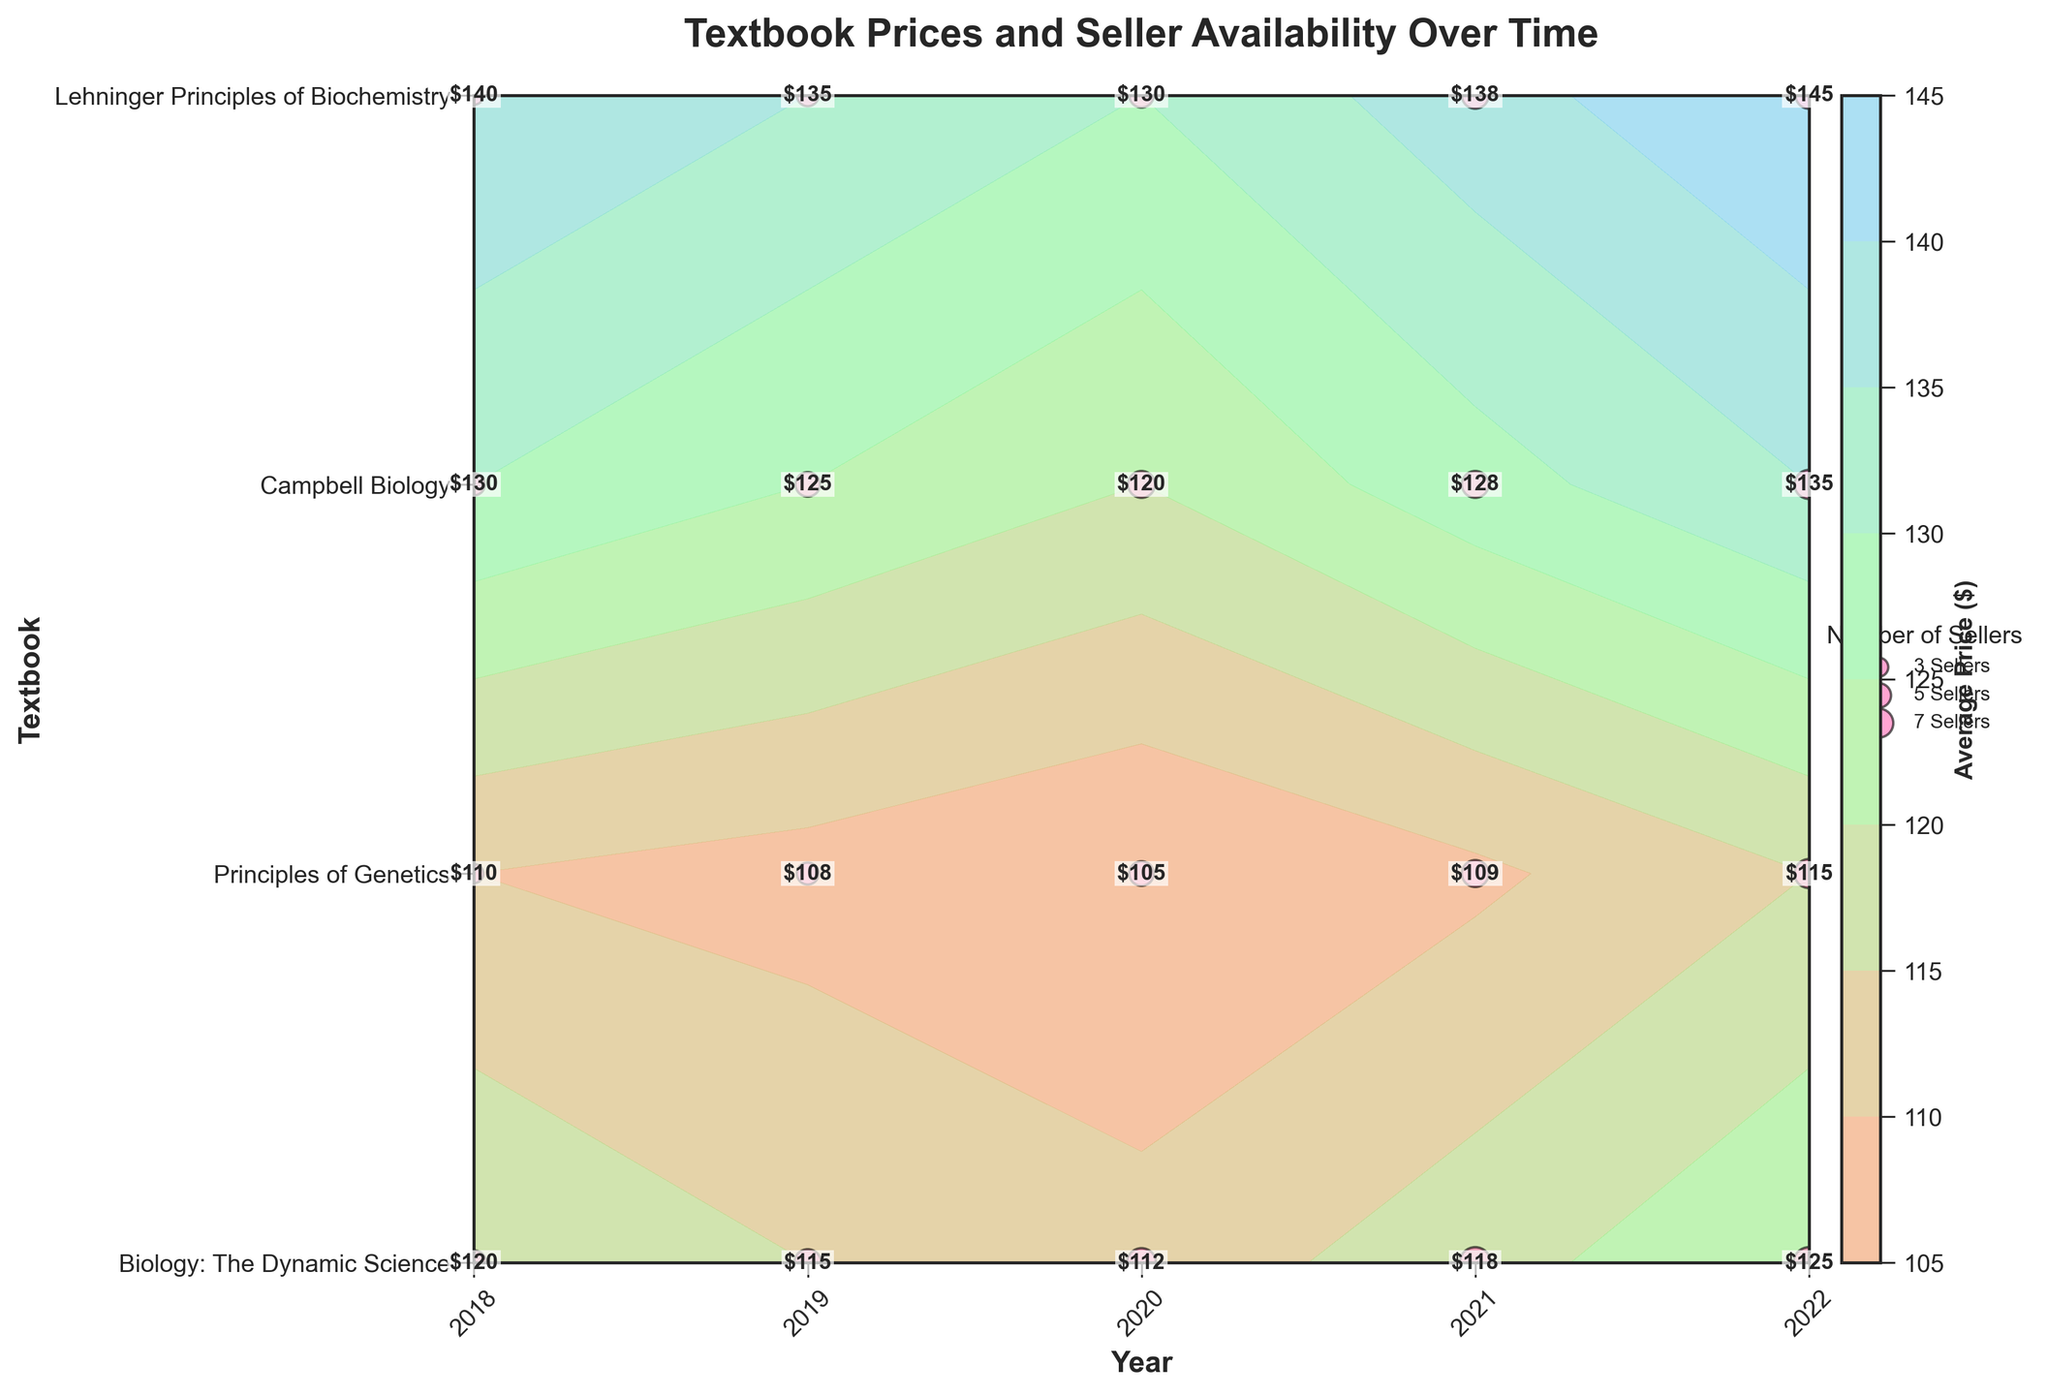Which textbook had the highest average price in 2022? To find the textbook with the highest average price in 2022, look at the year 2022 on the x-axis, then check the average price values for each textbook on the y-axis. The prices are labeled on the plot.
Answer: "Lehninger Principles of Biochemistry" How many sellers offered "Campbell Biology" in 2020? Look at the intersection of the year 2020 and the textbook "Campbell Biology". The number of sellers is indicated by the size of the markers on the scatter plot.
Answer: 6 Between 2018 and 2022, which textbook had the most consistent average price? To determine price consistency, look at the average prices for each year for each textbook. The textbook with minimal price fluctuation over the years has the most consistent prices.
Answer: "Principles of Genetics" Which year had the highest number of sellers for "Biology: The Dynamic Science"? Focus on the scatter plot markers at the "Biology: The Dynamic Science" row. Identify the year with the largest marker, representing the highest number of sellers.
Answer: 2021 or 2022 (tie with 8 sellers) What is the trend in the average price of "Principles of Genetics" from 2018 to 2022? Trace the contour labels for "Principles of Genetics" from 2018 to 2022. The average price appears to decrease slightly then rise.
Answer: Decrease then increase How does the average price of "Campbell Biology" in 2019 compare to "Lehninger Principles of Biochemistry" in the same year? Identify the average prices of both textbooks in 2019 from the labeled contour plot. Compare the numerical values.
Answer: Campbell Biology: $125, Lehninger Principles of Biochemistry: $135 In which year did "Biology: The Dynamic Science" have the lowest average price? Find the lowest price label for "Biology: The Dynamic Science" across the years.
Answer: 2020 What is the difference in the number of sellers for "Lehninger Principles of Biochemistry" between 2018 and 2022? Check the size of the markers for "Lehninger Principles of Biochemistry" in both 2018 and 2022, and calculate the difference.
Answer: 3 Which textbook saw the most significant increase in average price from 2021 to 2022? Compare the average prices of all textbooks in 2021 and 2022 and identify the one with the largest increase.
Answer: "Lehninger Principles of Biochemistry" 